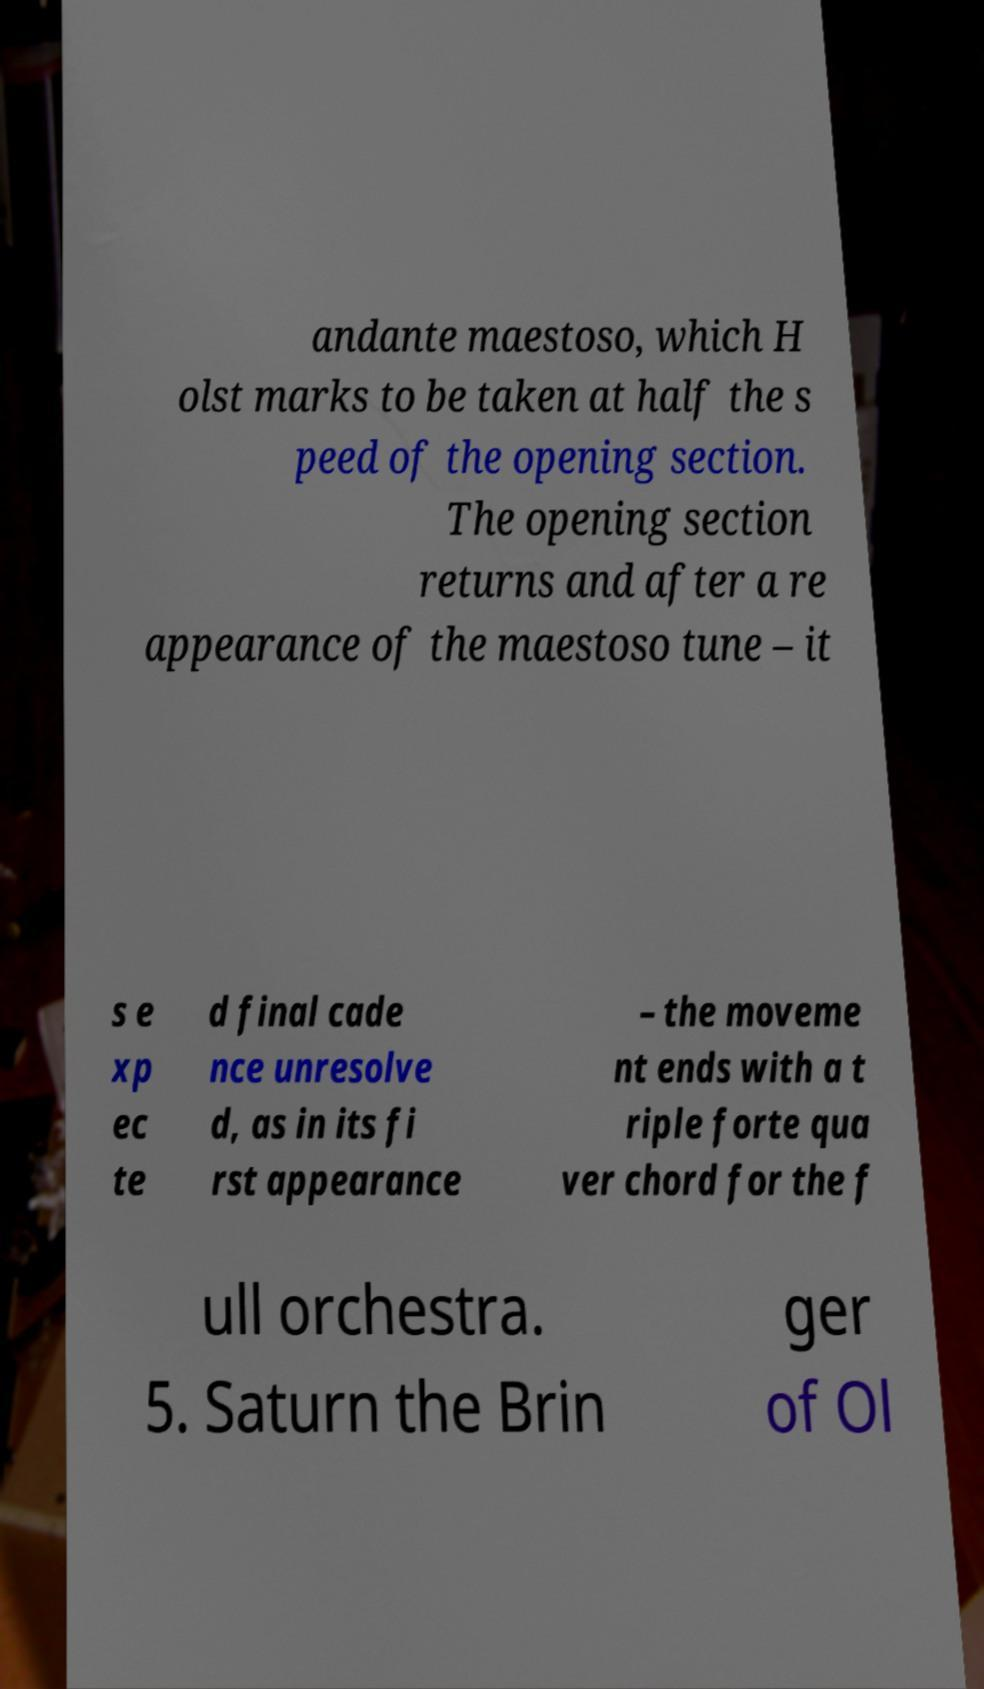For documentation purposes, I need the text within this image transcribed. Could you provide that? andante maestoso, which H olst marks to be taken at half the s peed of the opening section. The opening section returns and after a re appearance of the maestoso tune – it s e xp ec te d final cade nce unresolve d, as in its fi rst appearance – the moveme nt ends with a t riple forte qua ver chord for the f ull orchestra. 5. Saturn the Brin ger of Ol 